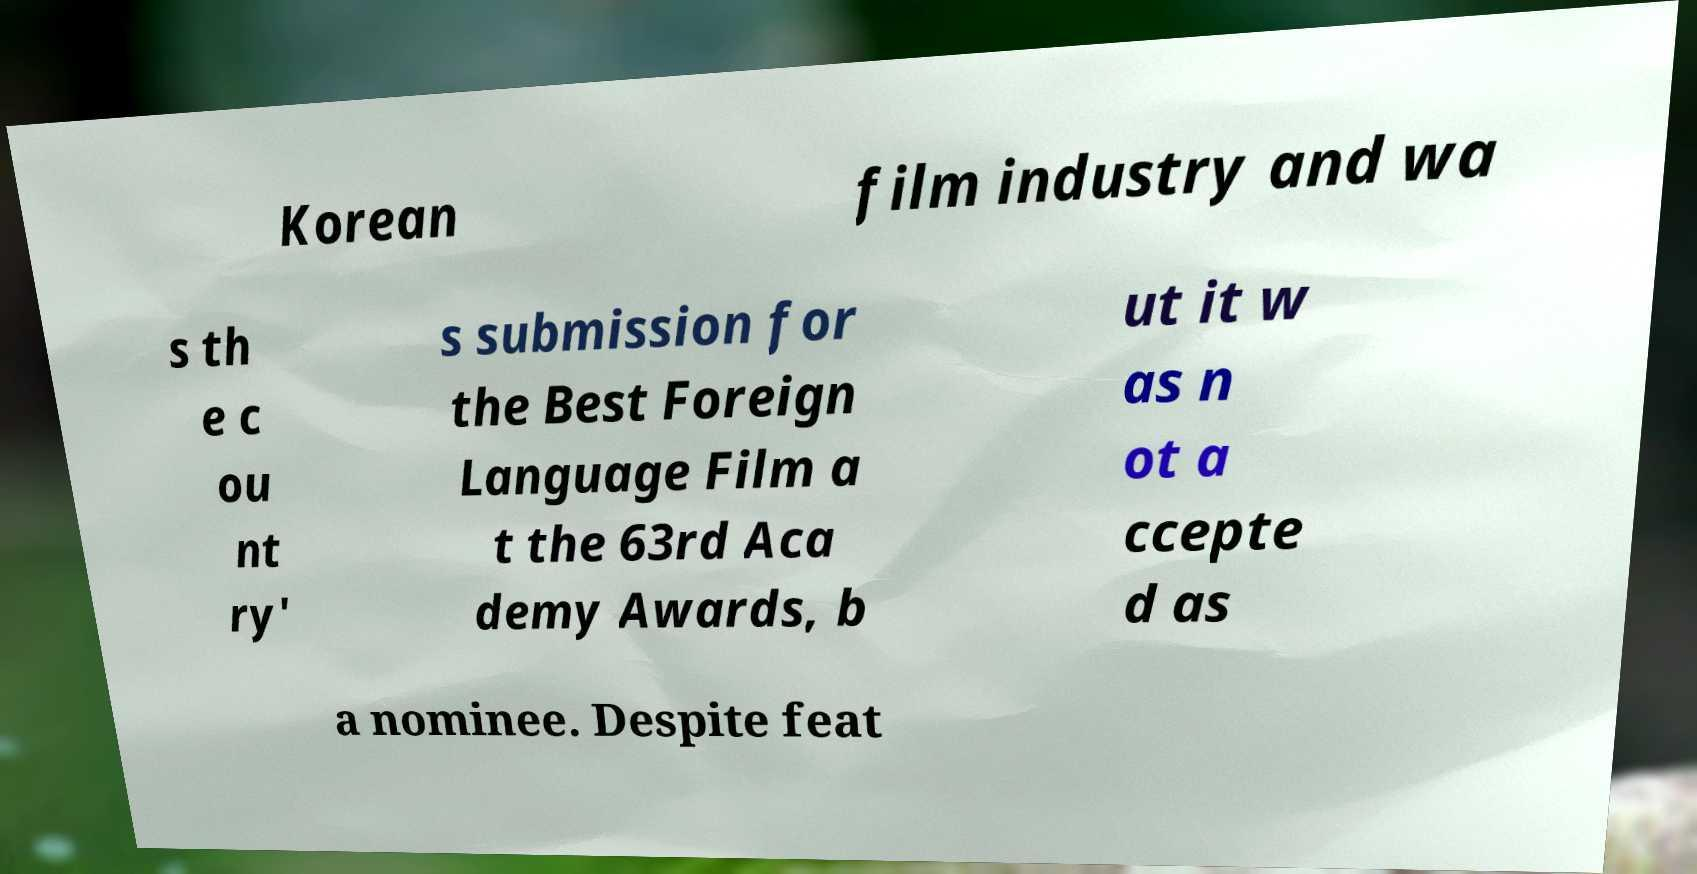Please identify and transcribe the text found in this image. Korean film industry and wa s th e c ou nt ry' s submission for the Best Foreign Language Film a t the 63rd Aca demy Awards, b ut it w as n ot a ccepte d as a nominee. Despite feat 